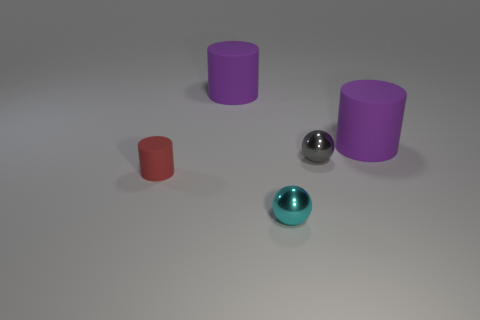Subtract all small matte cylinders. How many cylinders are left? 2 Subtract 1 cyan spheres. How many objects are left? 4 Subtract all balls. How many objects are left? 3 Subtract all brown cylinders. Subtract all purple spheres. How many cylinders are left? 3 Subtract all gray spheres. How many red cylinders are left? 1 Subtract all shiny things. Subtract all big purple cylinders. How many objects are left? 1 Add 2 gray metal balls. How many gray metal balls are left? 3 Add 4 large metallic spheres. How many large metallic spheres exist? 4 Add 1 gray metal cubes. How many objects exist? 6 Subtract all red cylinders. How many cylinders are left? 2 